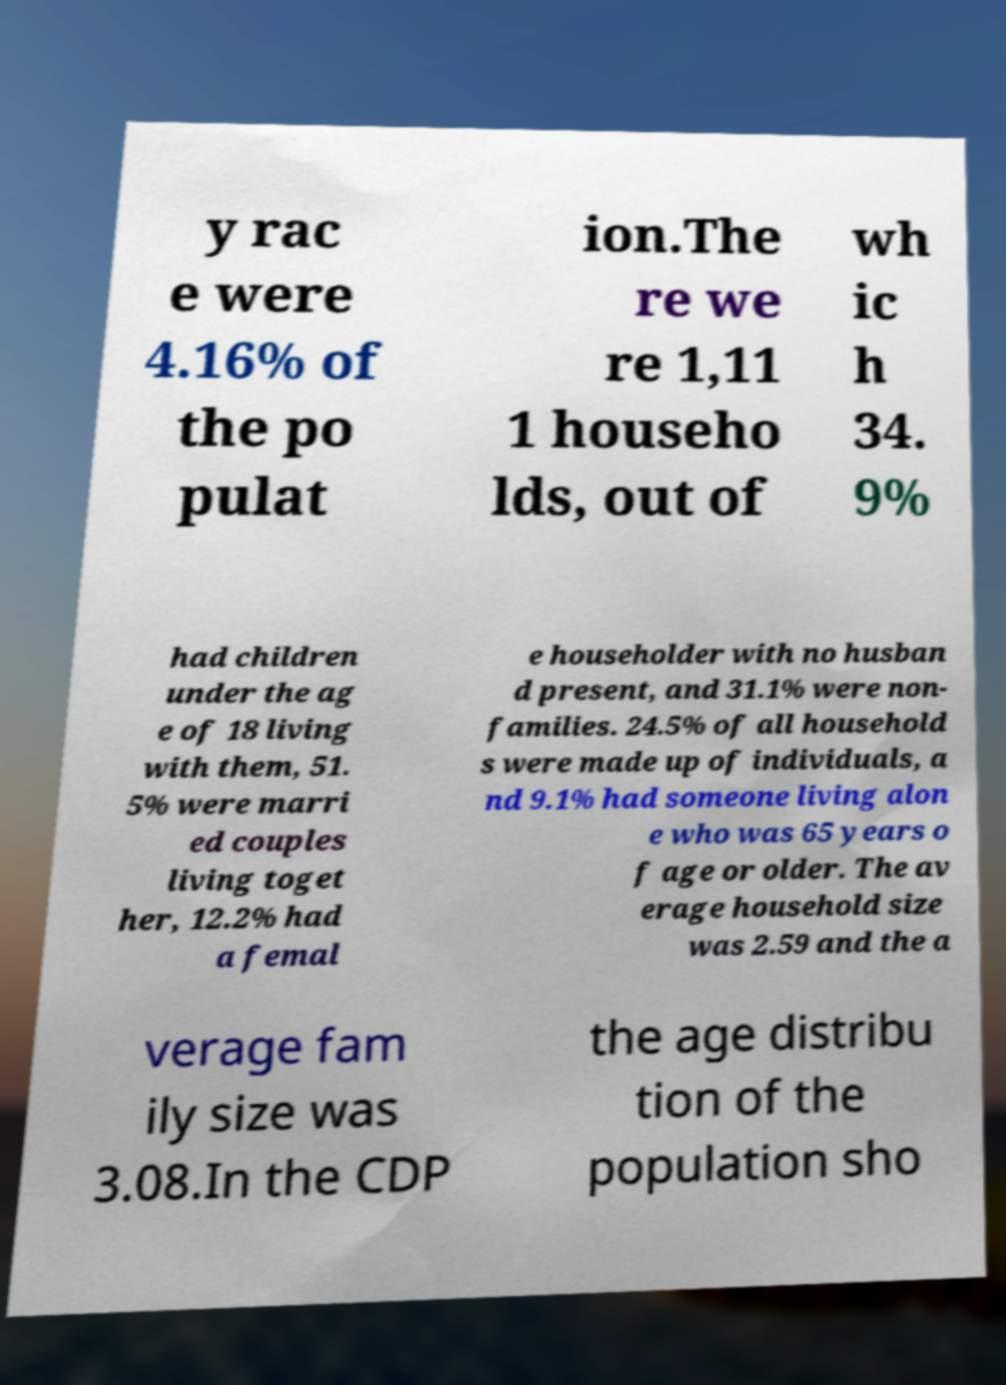There's text embedded in this image that I need extracted. Can you transcribe it verbatim? y rac e were 4.16% of the po pulat ion.The re we re 1,11 1 househo lds, out of wh ic h 34. 9% had children under the ag e of 18 living with them, 51. 5% were marri ed couples living toget her, 12.2% had a femal e householder with no husban d present, and 31.1% were non- families. 24.5% of all household s were made up of individuals, a nd 9.1% had someone living alon e who was 65 years o f age or older. The av erage household size was 2.59 and the a verage fam ily size was 3.08.In the CDP the age distribu tion of the population sho 